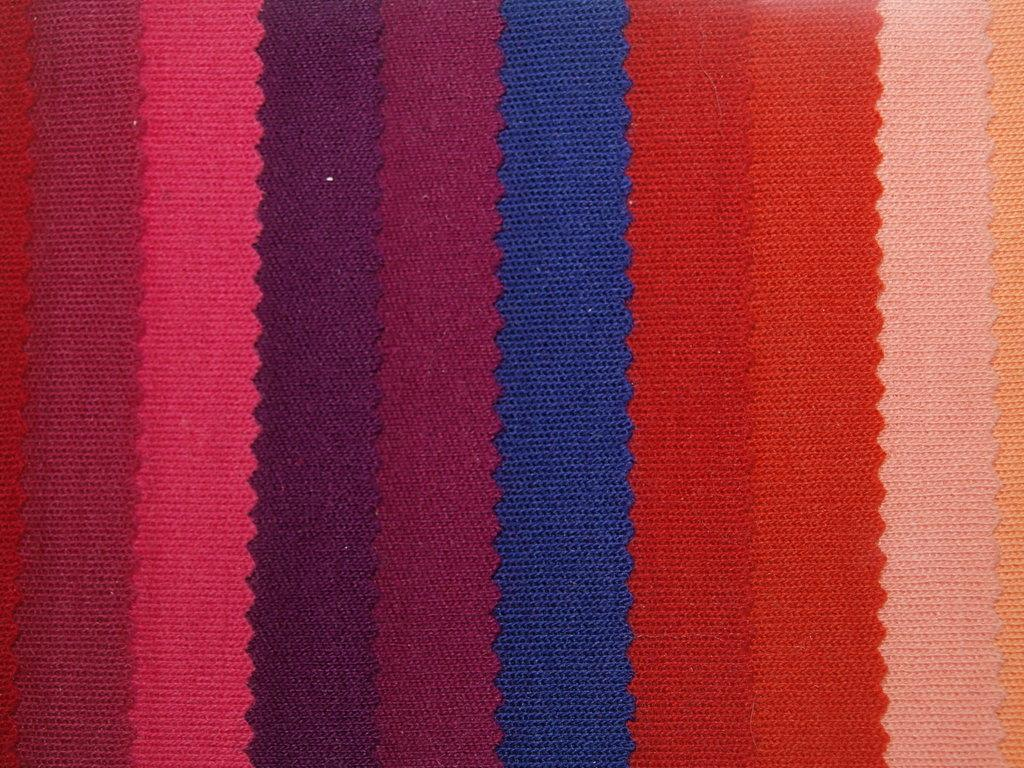What type of object is present in the image? The image contains a cloth. Can you describe the appearance of the cloth? The cloth has various colors. What type of road can be seen in the image? There is no road present in the image; it features a cloth with various colors. How many teeth can be seen on the cloth in the image? There are no teeth present on the cloth in the image. 